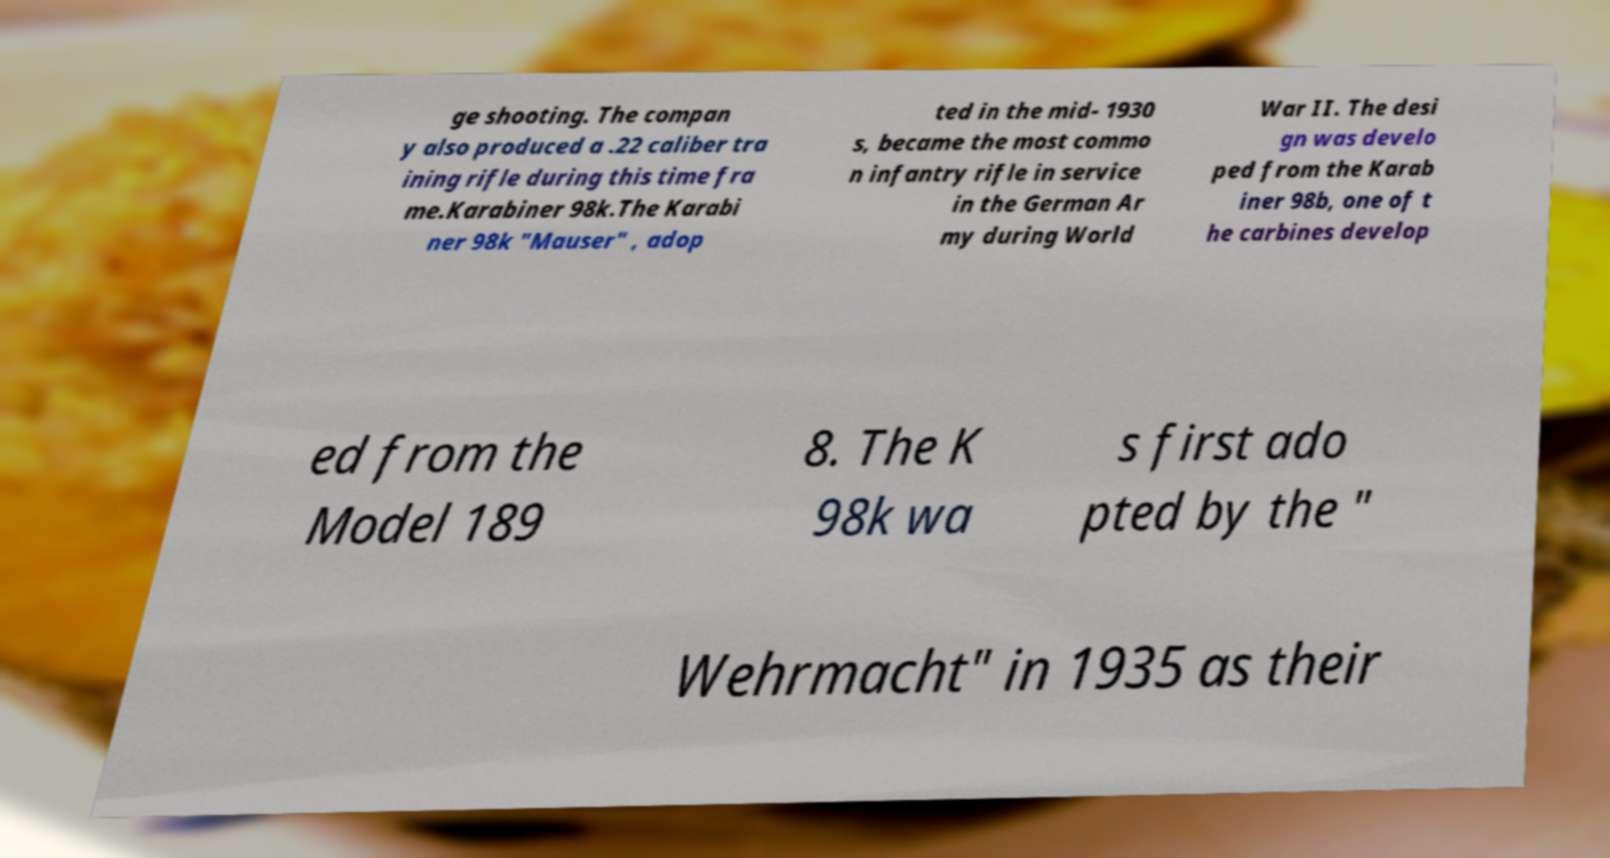Could you assist in decoding the text presented in this image and type it out clearly? ge shooting. The compan y also produced a .22 caliber tra ining rifle during this time fra me.Karabiner 98k.The Karabi ner 98k "Mauser" , adop ted in the mid- 1930 s, became the most commo n infantry rifle in service in the German Ar my during World War II. The desi gn was develo ped from the Karab iner 98b, one of t he carbines develop ed from the Model 189 8. The K 98k wa s first ado pted by the " Wehrmacht" in 1935 as their 